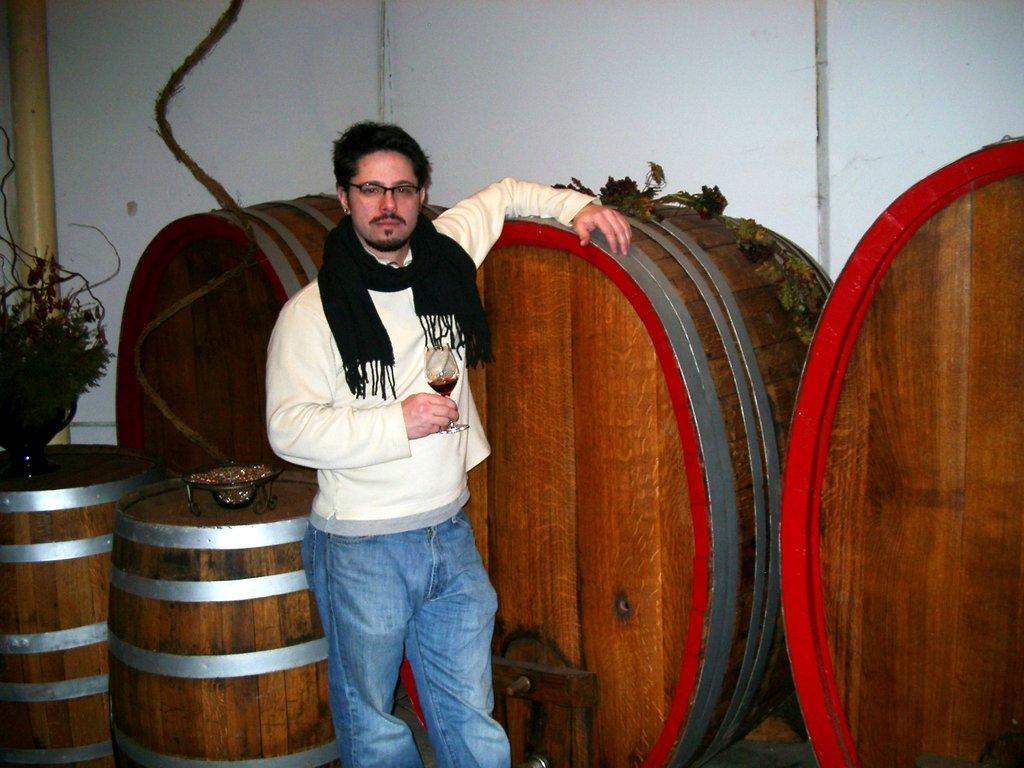Could you give a brief overview of what you see in this image? In this image we can see a person standing and holding a glass, there are some barrels, potted plant and some other objects, in the background we can see the wall. 